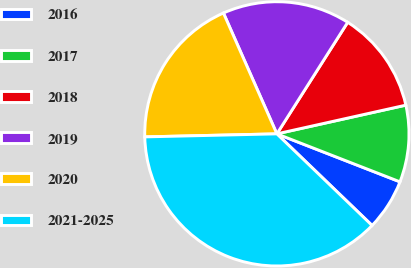Convert chart. <chart><loc_0><loc_0><loc_500><loc_500><pie_chart><fcel>2016<fcel>2017<fcel>2018<fcel>2019<fcel>2020<fcel>2021-2025<nl><fcel>6.28%<fcel>9.4%<fcel>12.51%<fcel>15.63%<fcel>18.74%<fcel>37.44%<nl></chart> 